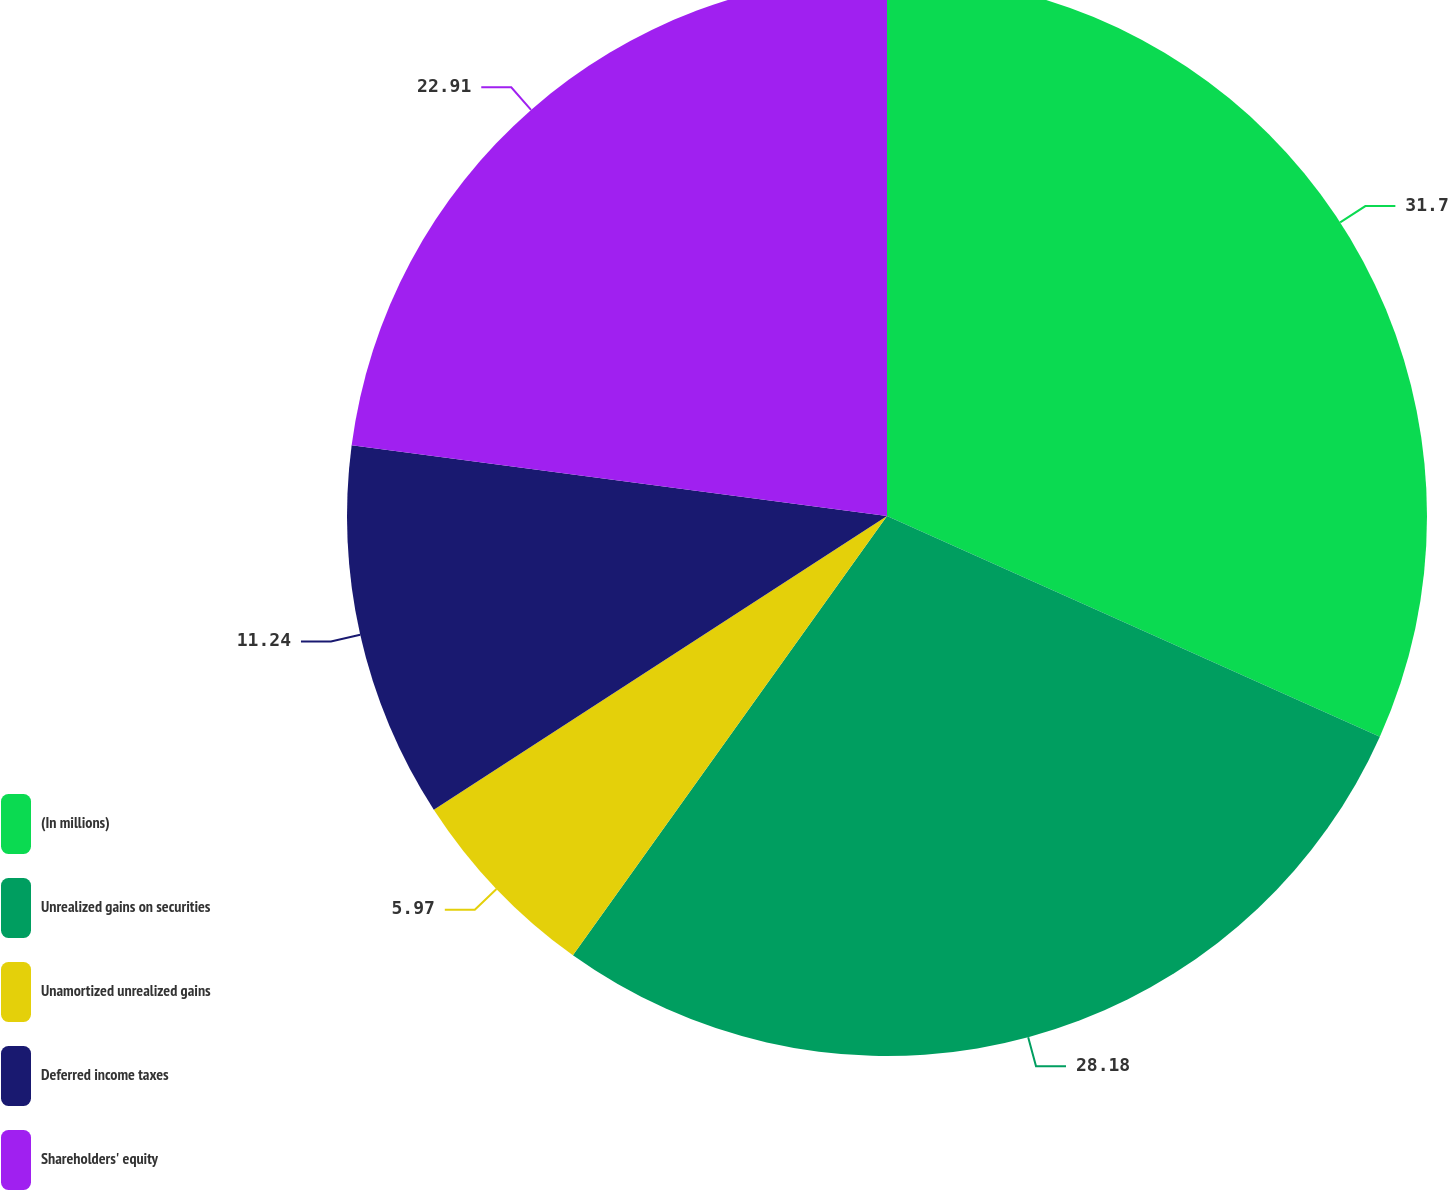<chart> <loc_0><loc_0><loc_500><loc_500><pie_chart><fcel>(In millions)<fcel>Unrealized gains on securities<fcel>Unamortized unrealized gains<fcel>Deferred income taxes<fcel>Shareholders' equity<nl><fcel>31.7%<fcel>28.18%<fcel>5.97%<fcel>11.24%<fcel>22.91%<nl></chart> 